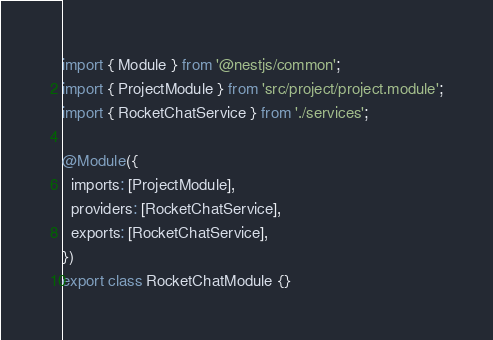<code> <loc_0><loc_0><loc_500><loc_500><_TypeScript_>import { Module } from '@nestjs/common';
import { ProjectModule } from 'src/project/project.module';
import { RocketChatService } from './services';

@Module({
  imports: [ProjectModule],
  providers: [RocketChatService],
  exports: [RocketChatService],
})
export class RocketChatModule {}
</code> 